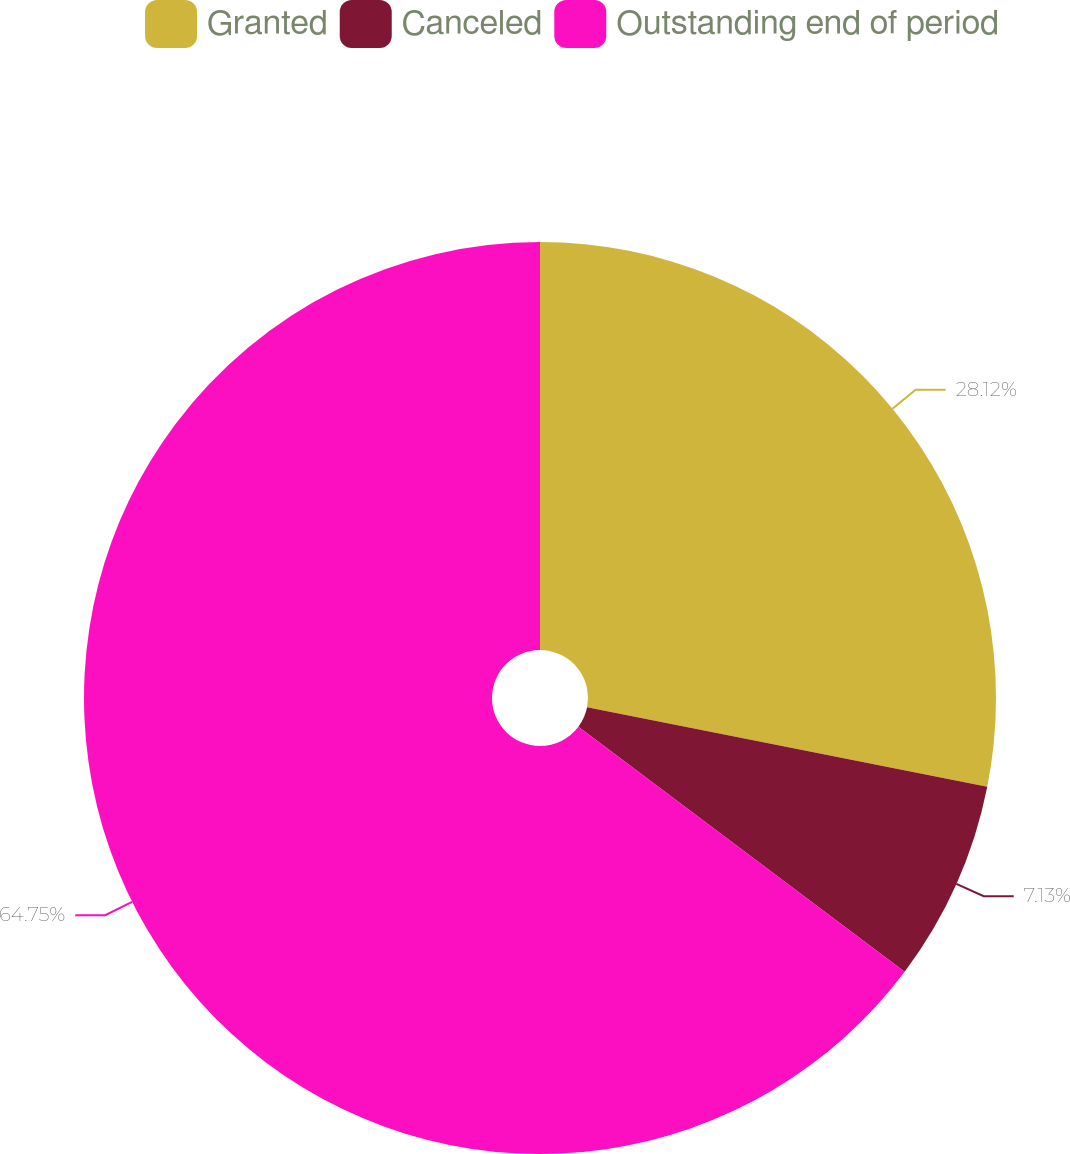Convert chart to OTSL. <chart><loc_0><loc_0><loc_500><loc_500><pie_chart><fcel>Granted<fcel>Canceled<fcel>Outstanding end of period<nl><fcel>28.12%<fcel>7.13%<fcel>64.75%<nl></chart> 